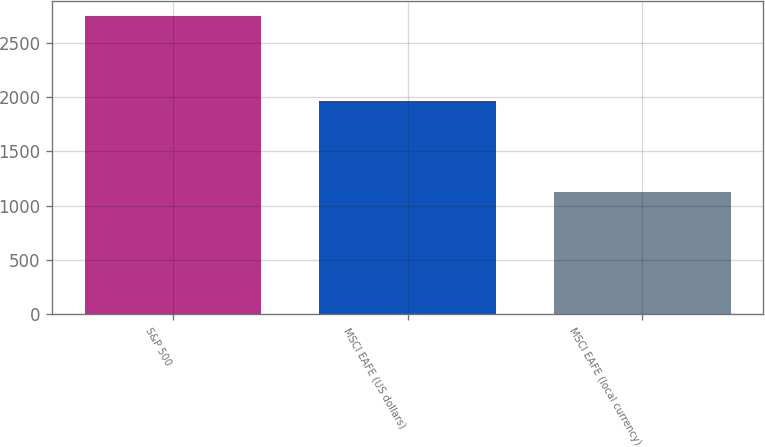<chart> <loc_0><loc_0><loc_500><loc_500><bar_chart><fcel>S&P 500<fcel>MSCI EAFE (US dollars)<fcel>MSCI EAFE (local currency)<nl><fcel>2746<fcel>1966<fcel>1125<nl></chart> 